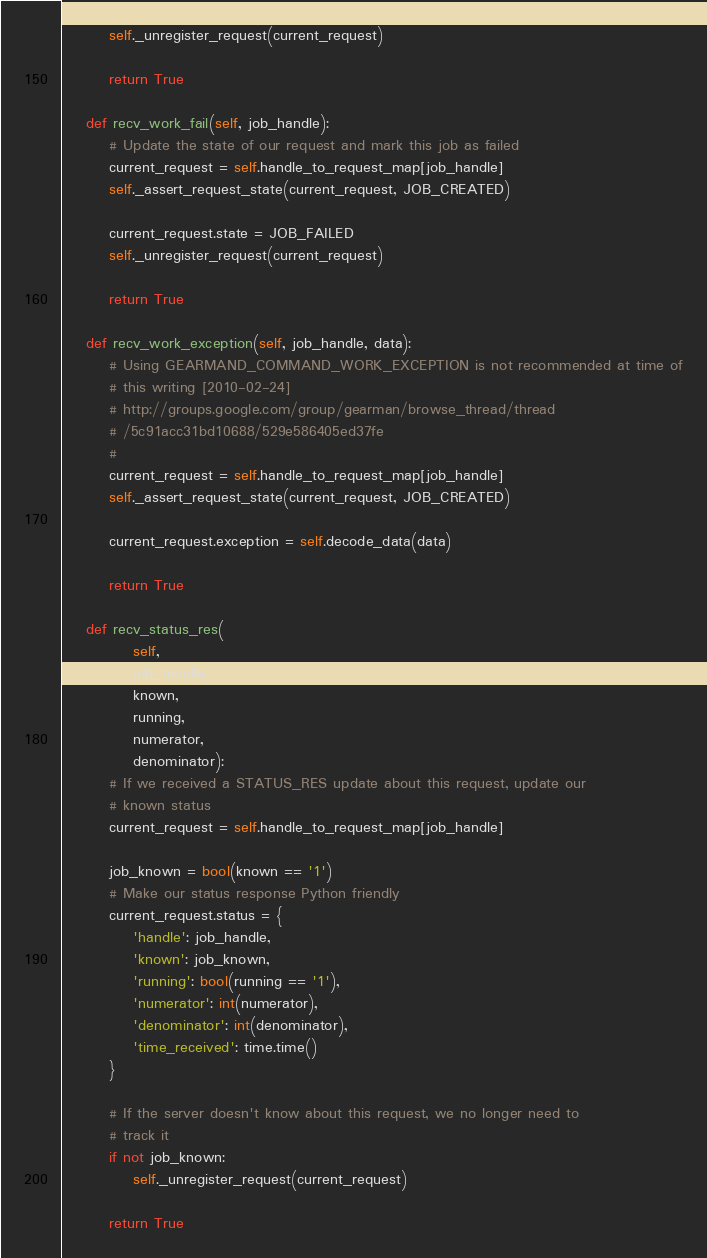Convert code to text. <code><loc_0><loc_0><loc_500><loc_500><_Python_>        self._unregister_request(current_request)

        return True

    def recv_work_fail(self, job_handle):
        # Update the state of our request and mark this job as failed
        current_request = self.handle_to_request_map[job_handle]
        self._assert_request_state(current_request, JOB_CREATED)

        current_request.state = JOB_FAILED
        self._unregister_request(current_request)

        return True

    def recv_work_exception(self, job_handle, data):
        # Using GEARMAND_COMMAND_WORK_EXCEPTION is not recommended at time of
        # this writing [2010-02-24]
        # http://groups.google.com/group/gearman/browse_thread/thread
        # /5c91acc31bd10688/529e586405ed37fe
        #
        current_request = self.handle_to_request_map[job_handle]
        self._assert_request_state(current_request, JOB_CREATED)

        current_request.exception = self.decode_data(data)

        return True

    def recv_status_res(
            self,
            job_handle,
            known,
            running,
            numerator,
            denominator):
        # If we received a STATUS_RES update about this request, update our
        # known status
        current_request = self.handle_to_request_map[job_handle]

        job_known = bool(known == '1')
        # Make our status response Python friendly
        current_request.status = {
            'handle': job_handle,
            'known': job_known,
            'running': bool(running == '1'),
            'numerator': int(numerator),
            'denominator': int(denominator),
            'time_received': time.time()
        }

        # If the server doesn't know about this request, we no longer need to
        # track it
        if not job_known:
            self._unregister_request(current_request)

        return True
</code> 